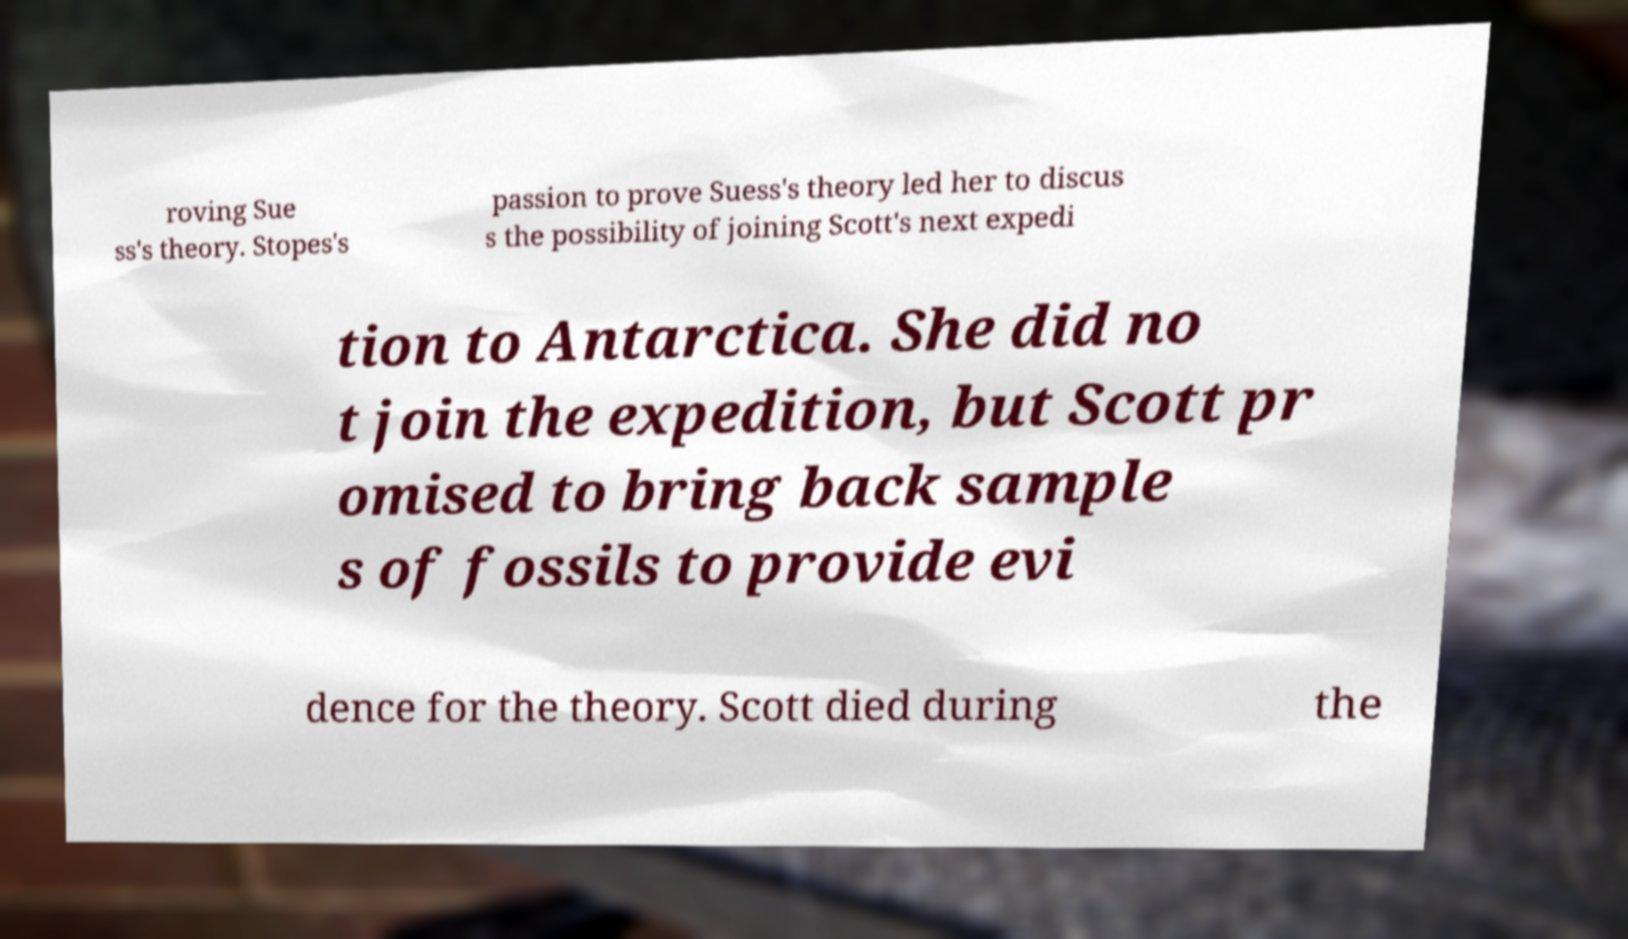Can you accurately transcribe the text from the provided image for me? roving Sue ss's theory. Stopes's passion to prove Suess's theory led her to discus s the possibility of joining Scott's next expedi tion to Antarctica. She did no t join the expedition, but Scott pr omised to bring back sample s of fossils to provide evi dence for the theory. Scott died during the 